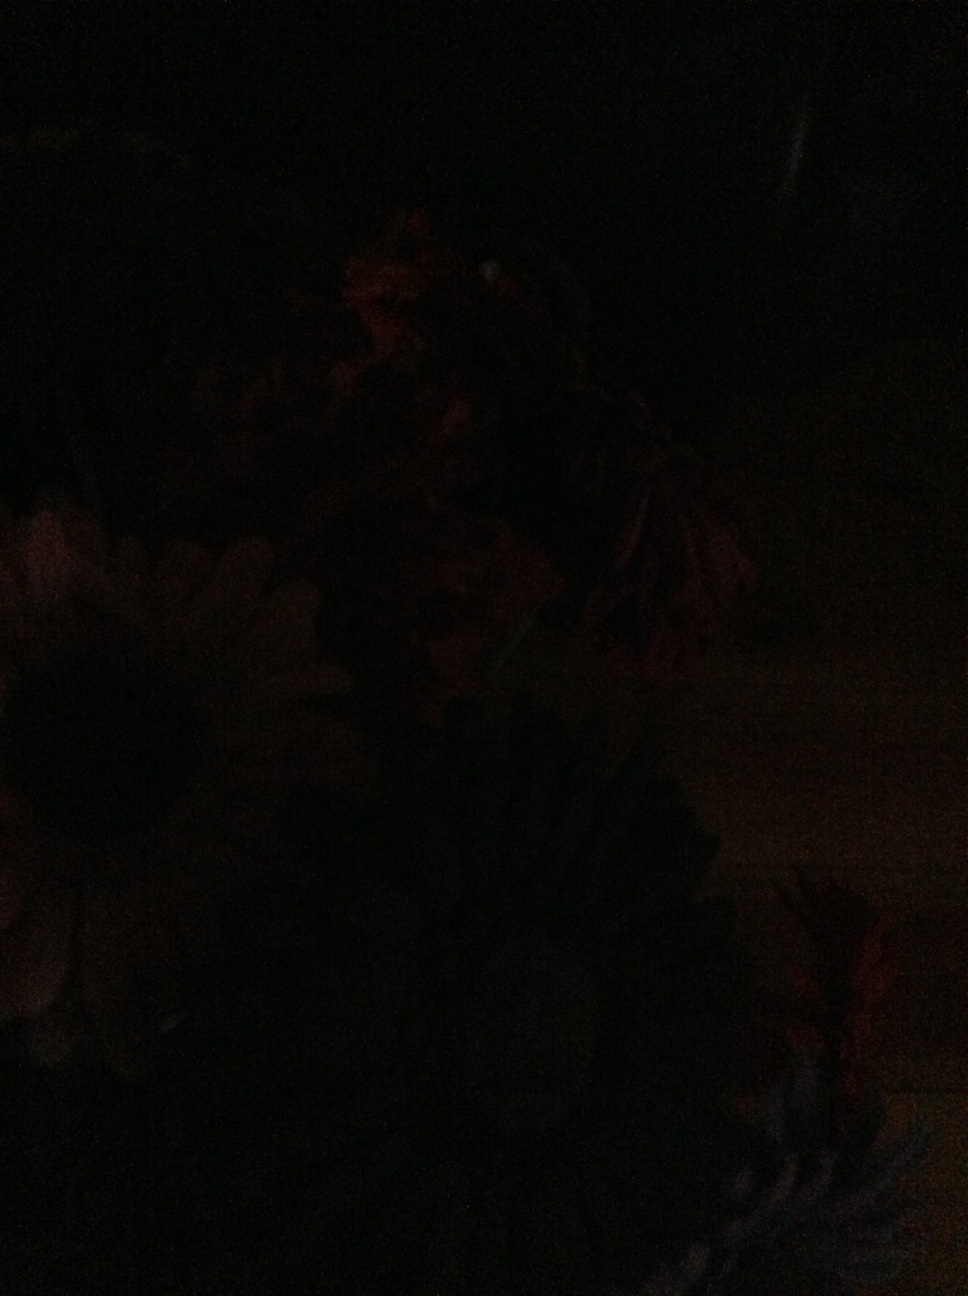Color of the flower. The image is quite dark and the details are not clearly visible, making it difficult to determine the color of the flower. 